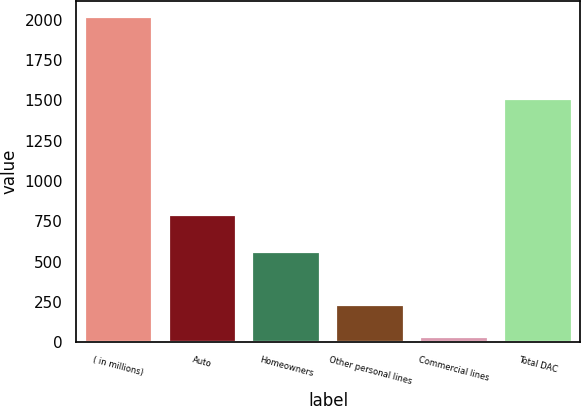Convert chart. <chart><loc_0><loc_0><loc_500><loc_500><bar_chart><fcel>( in millions)<fcel>Auto<fcel>Homeowners<fcel>Other personal lines<fcel>Commercial lines<fcel>Total DAC<nl><fcel>2017<fcel>789<fcel>558<fcel>229.6<fcel>31<fcel>1510<nl></chart> 